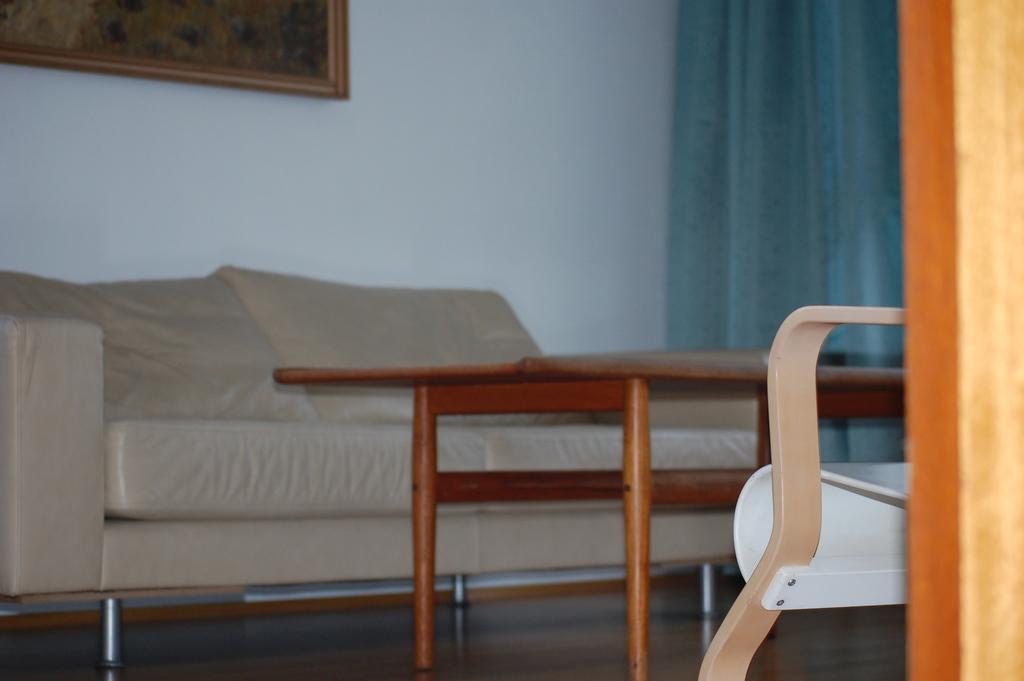Can you describe this image briefly? It is a closed room with a sofa and a table in the middle and the curtains at the right corner of the picture and there is a wall behind the sofa and a picture on it. 